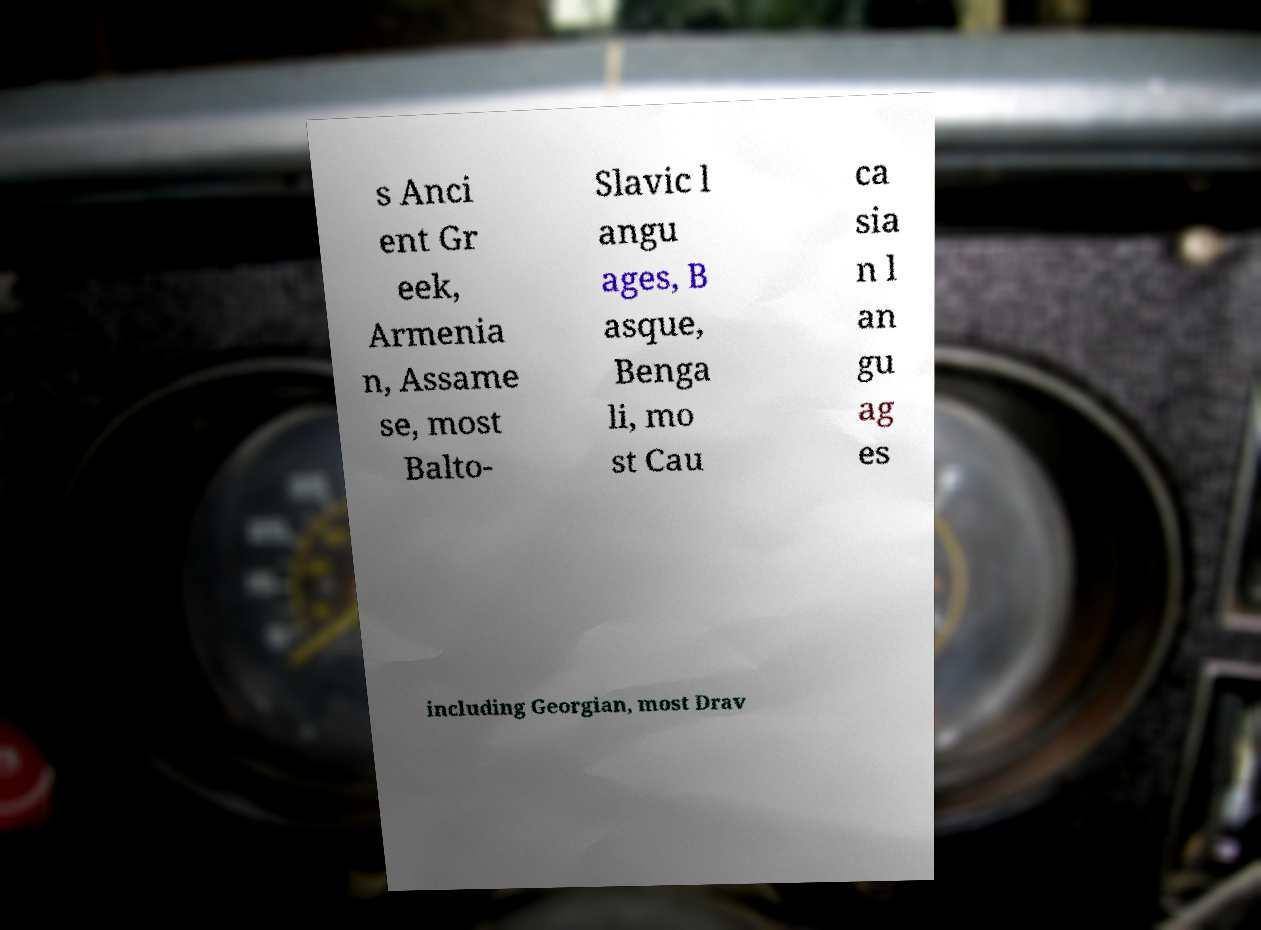Could you assist in decoding the text presented in this image and type it out clearly? s Anci ent Gr eek, Armenia n, Assame se, most Balto- Slavic l angu ages, B asque, Benga li, mo st Cau ca sia n l an gu ag es including Georgian, most Drav 